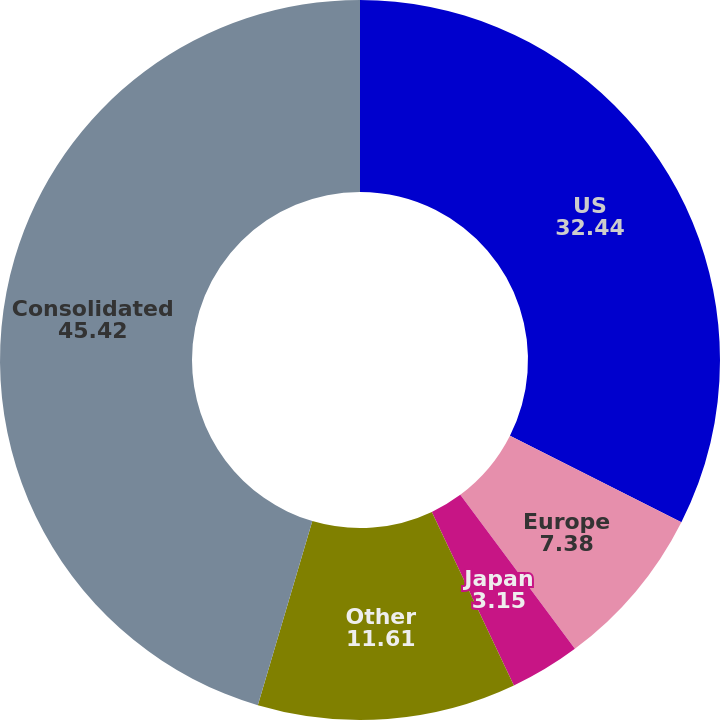Convert chart. <chart><loc_0><loc_0><loc_500><loc_500><pie_chart><fcel>US<fcel>Europe<fcel>Japan<fcel>Other<fcel>Consolidated<nl><fcel>32.44%<fcel>7.38%<fcel>3.15%<fcel>11.61%<fcel>45.42%<nl></chart> 